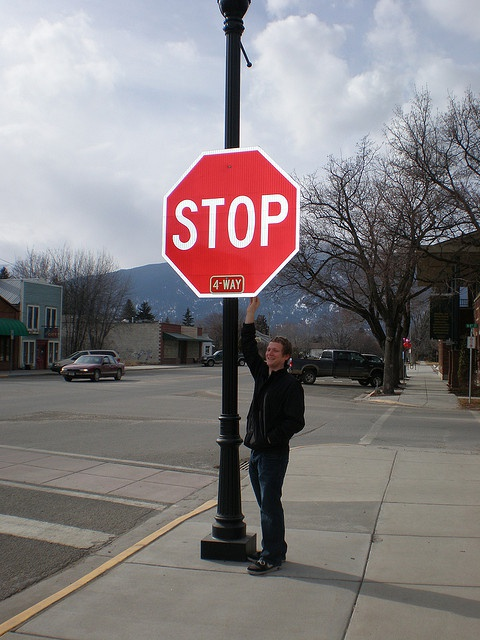Describe the objects in this image and their specific colors. I can see stop sign in lightgray, brown, white, and red tones, people in lightgray, black, gray, and maroon tones, car in lightgray, black, gray, and maroon tones, car in lightgray, black, gray, and darkgray tones, and car in lightgray, black, and gray tones in this image. 